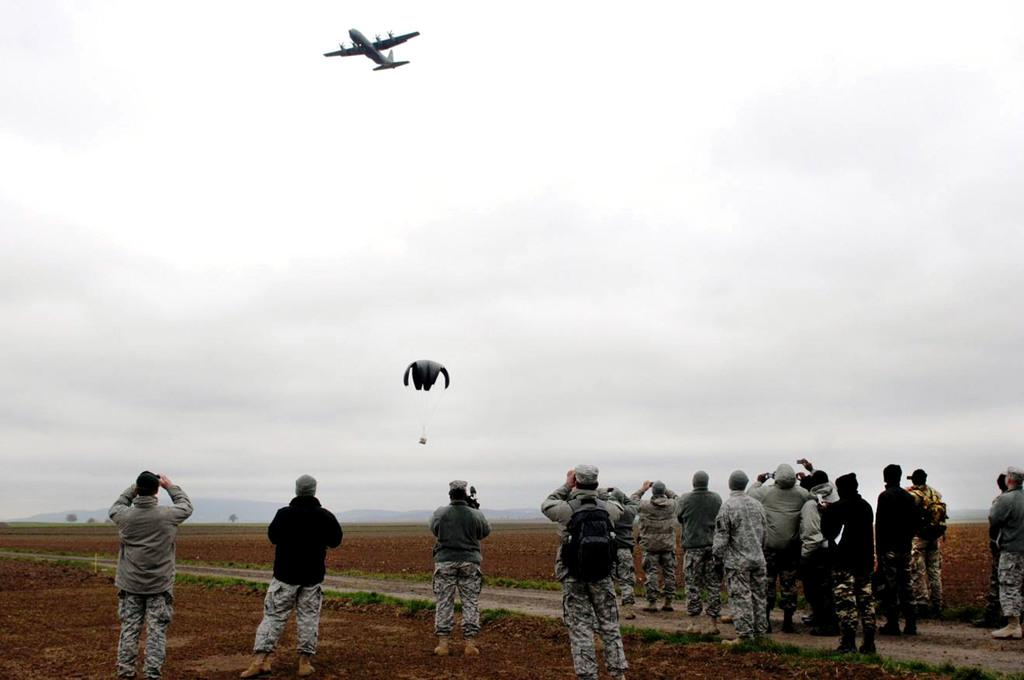What is in the sky in the image? There is an airplane and a parachute in the sky. What are the people on the ground doing? The people standing on the ground are wearing uniforms. What can be seen in the background of the image? There are hills and trees in the background. What type of ornament is hanging from the parachute in the image? There is no ornament hanging from the parachute in the image. What time is the meeting scheduled for in the image? There is no meeting depicted in the image, so it is not possible to determine the time. 